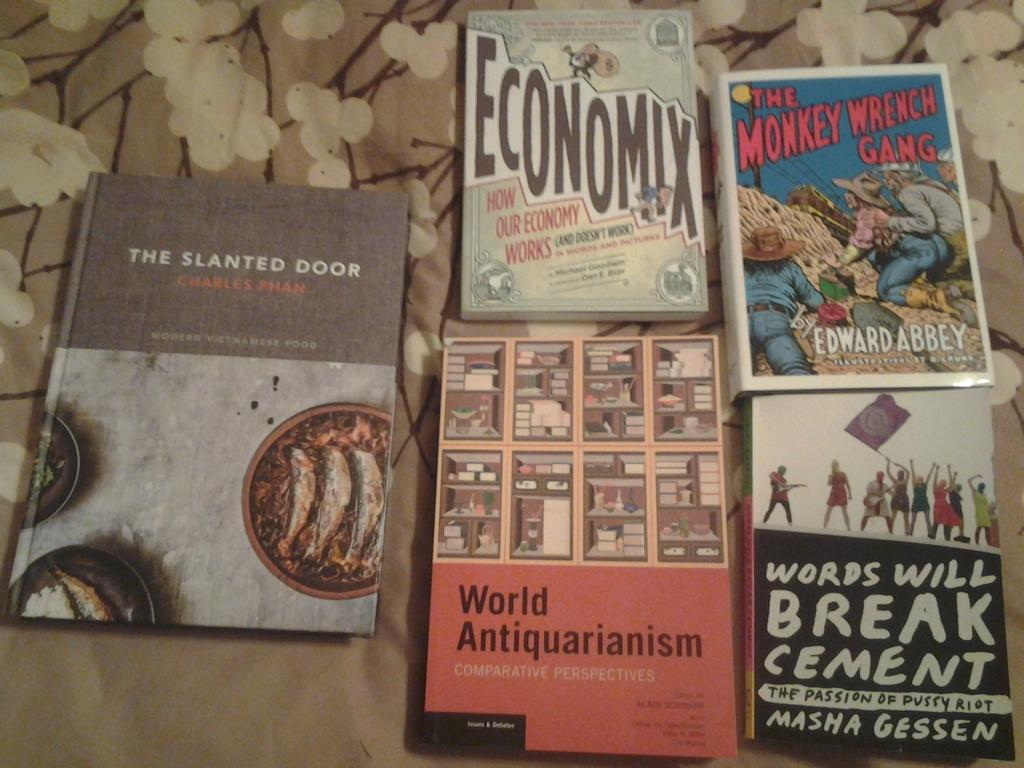Provide a one-sentence caption for the provided image. Five books, including The Monkey Wrench Gang, lay next to each other. 